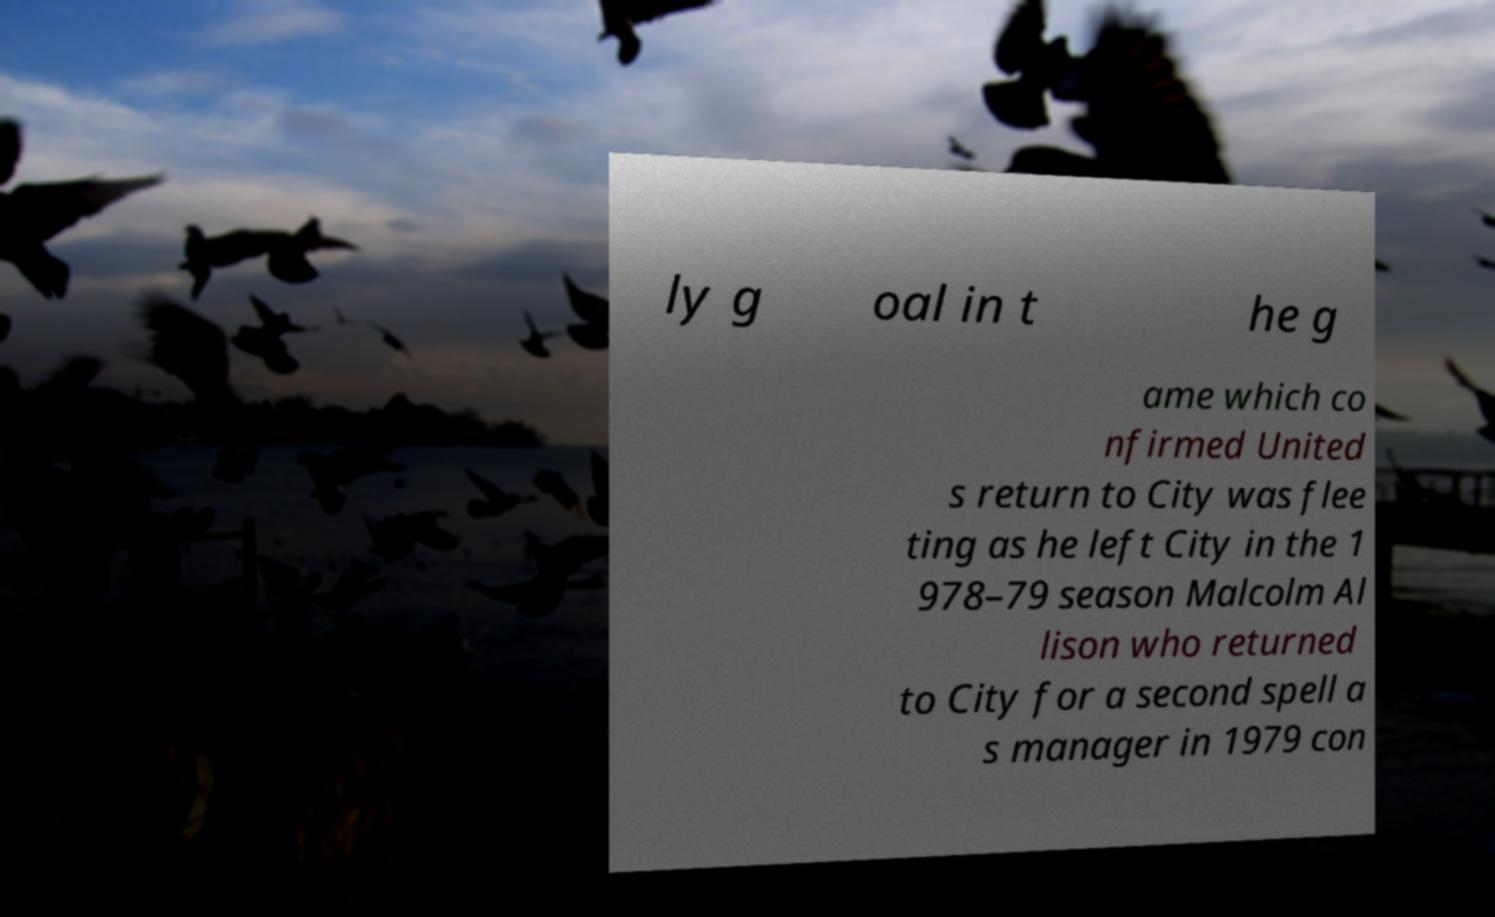I need the written content from this picture converted into text. Can you do that? ly g oal in t he g ame which co nfirmed United s return to City was flee ting as he left City in the 1 978–79 season Malcolm Al lison who returned to City for a second spell a s manager in 1979 con 